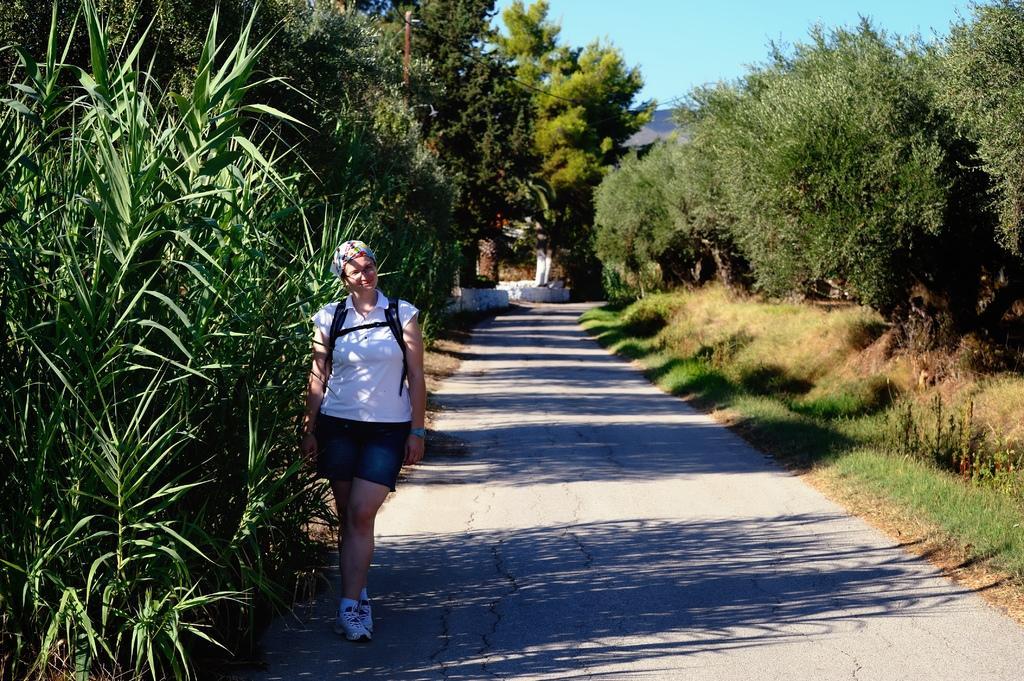Describe this image in one or two sentences. In this picture there is a woman. She is wearing spectacle, cap, t-shirt, big, short, watch and shoe. She is standing on the road beside the plants. On the background we can see many trees. On the right we can see grass. On the top there is a sky. Here we can see a building. 